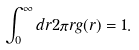Convert formula to latex. <formula><loc_0><loc_0><loc_500><loc_500>\int _ { 0 } ^ { \infty } d r 2 \pi r g ( r ) = 1 .</formula> 